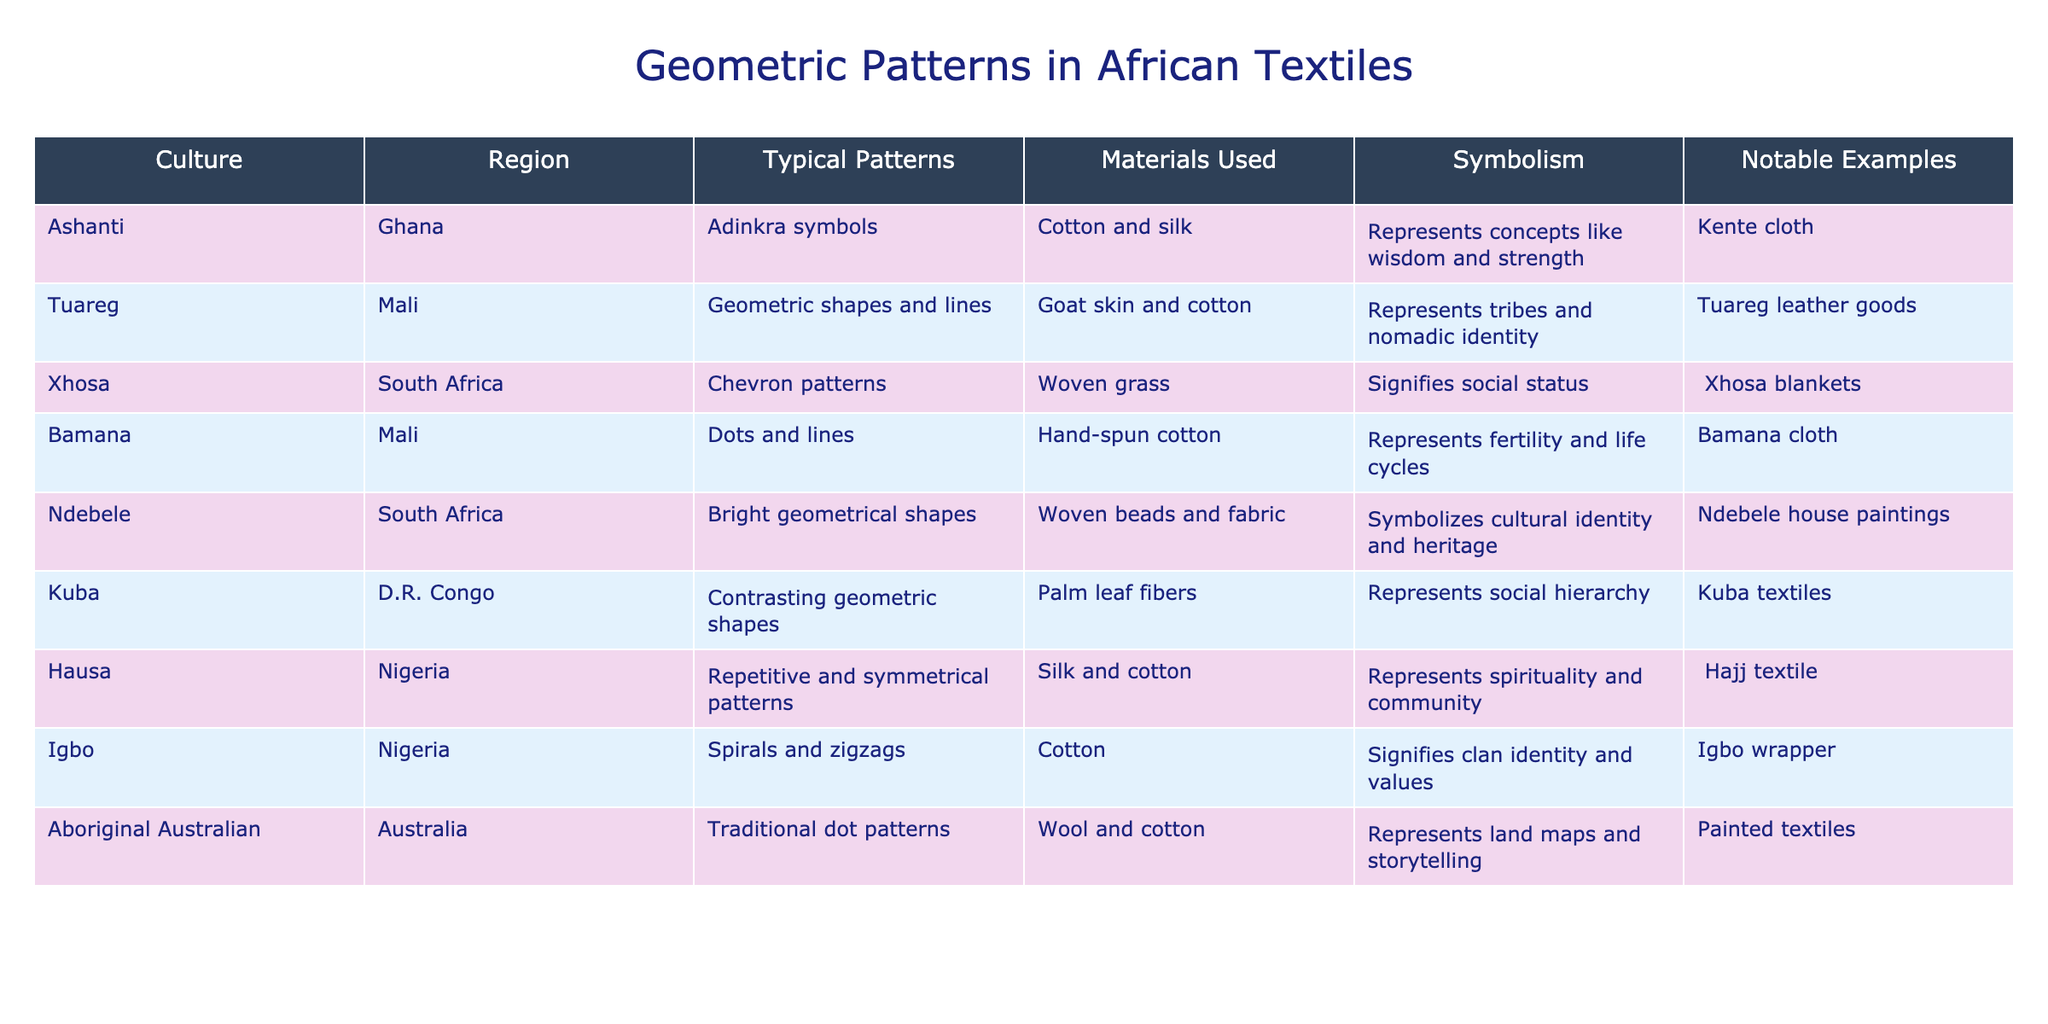What is the typical quality of materials used in Ashanti textiles? The table indicates that Ashanti textiles use cotton and silk as materials.
Answer: Cotton and silk Which culture uses woven grass and what do their patterns signify? The Xhosa culture uses woven grass for their textiles, and their chevron patterns signify social status.
Answer: Xhosa; social status What are the notable examples of geometric patterns in Ndebele art? The notable examples of geometric patterns in Ndebele art include their house paintings, which feature bright geometrical shapes.
Answer: Ndebele house paintings How many cultures listed use cotton as a primary material? From the table, the cultures that use cotton are Ashanti, Bamana, Igbo, and Hausa. That counts as four cultures.
Answer: Four Is the symbolism of tribal identity associated with Tuareg geometric patterns? Yes, the symbolism associated with Tuareg patterns represents tribes and nomadic identity.
Answer: Yes Which culture's patterns are represented by spirals and zigzags, and what do they signify? The Igbo culture's patterns are characterized by spirals and zigzags, which signify clan identity and values.
Answer: Igbo; clan identity and values Do all cultures listed have a specific symbolism associated with their geometric patterns? Yes, the table indicates every culture has at least one symbolic meaning associated with their patterns.
Answer: Yes Which culture has the most diverse types of geometric patterns based on the table? The Ndebele culture features bright geometrical shapes, which is quite diverse compared to the others, but for a comparison, the Ashanti’s Adinkra symbols could also be seen as diverse.
Answer: Ndebele (or Ashanti, depending on what diversity means) What is the common theme of the symbols represented in Bamana textiles? The symbols in Bamana textiles represent fertility and life cycles, which reflects a common theme related to growth and continuation.
Answer: Fertility and life cycles Which culture's patterns are made of dyed goat skin, and what is their cultural significance? The Tuareg culture uses dyed goat skin for their geometric patterns, which signifies tribes and nomadic identity.
Answer: Tuareg; tribes and nomadic identity 